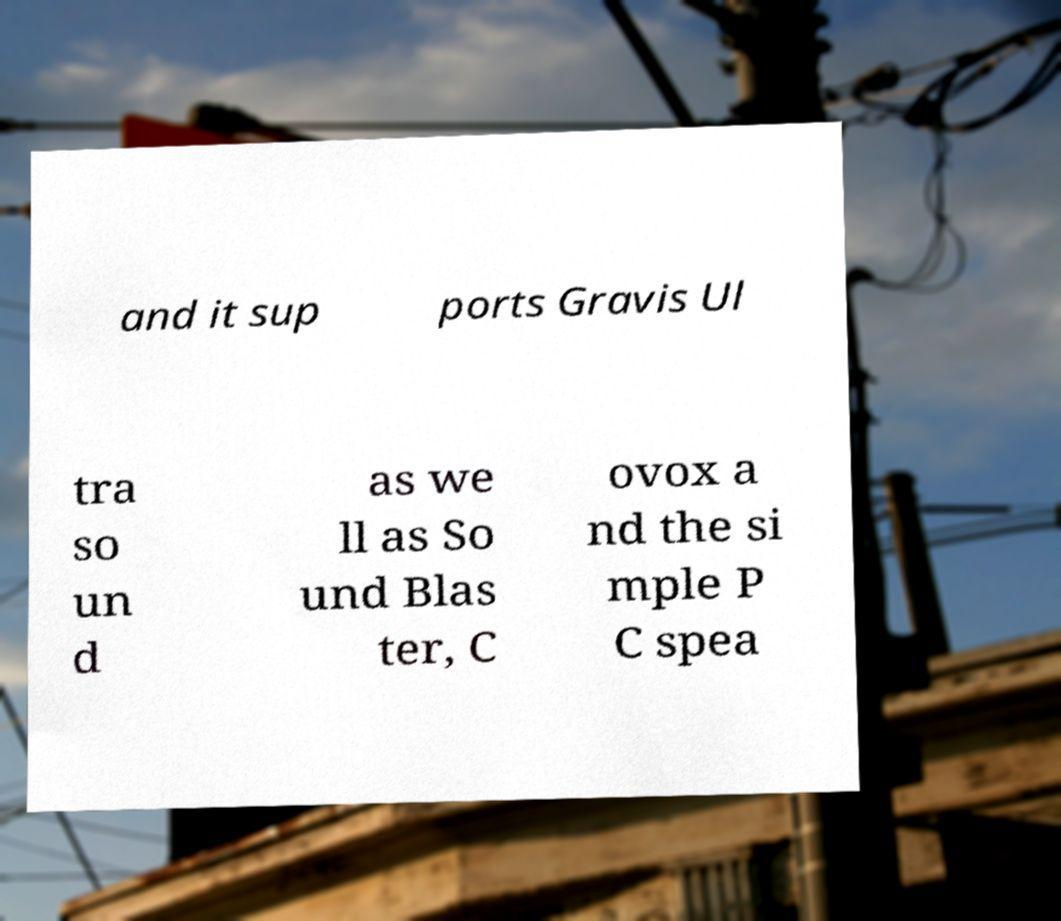There's text embedded in this image that I need extracted. Can you transcribe it verbatim? and it sup ports Gravis Ul tra so un d as we ll as So und Blas ter, C ovox a nd the si mple P C spea 